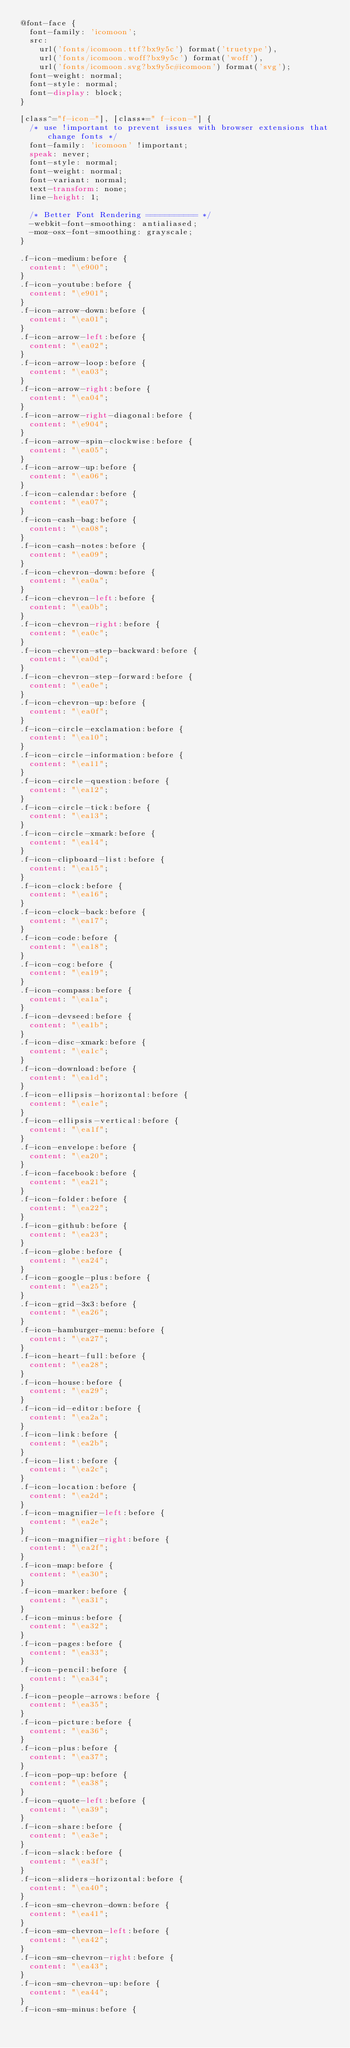Convert code to text. <code><loc_0><loc_0><loc_500><loc_500><_CSS_>@font-face {
  font-family: 'icomoon';
  src:
    url('fonts/icomoon.ttf?bx9y5c') format('truetype'),
    url('fonts/icomoon.woff?bx9y5c') format('woff'),
    url('fonts/icomoon.svg?bx9y5c#icomoon') format('svg');
  font-weight: normal;
  font-style: normal;
  font-display: block;
}

[class^="f-icon-"], [class*=" f-icon-"] {
  /* use !important to prevent issues with browser extensions that change fonts */
  font-family: 'icomoon' !important;
  speak: never;
  font-style: normal;
  font-weight: normal;
  font-variant: normal;
  text-transform: none;
  line-height: 1;

  /* Better Font Rendering =========== */
  -webkit-font-smoothing: antialiased;
  -moz-osx-font-smoothing: grayscale;
}

.f-icon-medium:before {
  content: "\e900";
}
.f-icon-youtube:before {
  content: "\e901";
}
.f-icon-arrow-down:before {
  content: "\ea01";
}
.f-icon-arrow-left:before {
  content: "\ea02";
}
.f-icon-arrow-loop:before {
  content: "\ea03";
}
.f-icon-arrow-right:before {
  content: "\ea04";
}
.f-icon-arrow-right-diagonal:before {
  content: "\e904";
}
.f-icon-arrow-spin-clockwise:before {
  content: "\ea05";
}
.f-icon-arrow-up:before {
  content: "\ea06";
}
.f-icon-calendar:before {
  content: "\ea07";
}
.f-icon-cash-bag:before {
  content: "\ea08";
}
.f-icon-cash-notes:before {
  content: "\ea09";
}
.f-icon-chevron-down:before {
  content: "\ea0a";
}
.f-icon-chevron-left:before {
  content: "\ea0b";
}
.f-icon-chevron-right:before {
  content: "\ea0c";
}
.f-icon-chevron-step-backward:before {
  content: "\ea0d";
}
.f-icon-chevron-step-forward:before {
  content: "\ea0e";
}
.f-icon-chevron-up:before {
  content: "\ea0f";
}
.f-icon-circle-exclamation:before {
  content: "\ea10";
}
.f-icon-circle-information:before {
  content: "\ea11";
}
.f-icon-circle-question:before {
  content: "\ea12";
}
.f-icon-circle-tick:before {
  content: "\ea13";
}
.f-icon-circle-xmark:before {
  content: "\ea14";
}
.f-icon-clipboard-list:before {
  content: "\ea15";
}
.f-icon-clock:before {
  content: "\ea16";
}
.f-icon-clock-back:before {
  content: "\ea17";
}
.f-icon-code:before {
  content: "\ea18";
}
.f-icon-cog:before {
  content: "\ea19";
}
.f-icon-compass:before {
  content: "\ea1a";
}
.f-icon-devseed:before {
  content: "\ea1b";
}
.f-icon-disc-xmark:before {
  content: "\ea1c";
}
.f-icon-download:before {
  content: "\ea1d";
}
.f-icon-ellipsis-horizontal:before {
  content: "\ea1e";
}
.f-icon-ellipsis-vertical:before {
  content: "\ea1f";
}
.f-icon-envelope:before {
  content: "\ea20";
}
.f-icon-facebook:before {
  content: "\ea21";
}
.f-icon-folder:before {
  content: "\ea22";
}
.f-icon-github:before {
  content: "\ea23";
}
.f-icon-globe:before {
  content: "\ea24";
}
.f-icon-google-plus:before {
  content: "\ea25";
}
.f-icon-grid-3x3:before {
  content: "\ea26";
}
.f-icon-hamburger-menu:before {
  content: "\ea27";
}
.f-icon-heart-full:before {
  content: "\ea28";
}
.f-icon-house:before {
  content: "\ea29";
}
.f-icon-id-editor:before {
  content: "\ea2a";
}
.f-icon-link:before {
  content: "\ea2b";
}
.f-icon-list:before {
  content: "\ea2c";
}
.f-icon-location:before {
  content: "\ea2d";
}
.f-icon-magnifier-left:before {
  content: "\ea2e";
}
.f-icon-magnifier-right:before {
  content: "\ea2f";
}
.f-icon-map:before {
  content: "\ea30";
}
.f-icon-marker:before {
  content: "\ea31";
}
.f-icon-minus:before {
  content: "\ea32";
}
.f-icon-pages:before {
  content: "\ea33";
}
.f-icon-pencil:before {
  content: "\ea34";
}
.f-icon-people-arrows:before {
  content: "\ea35";
}
.f-icon-picture:before {
  content: "\ea36";
}
.f-icon-plus:before {
  content: "\ea37";
}
.f-icon-pop-up:before {
  content: "\ea38";
}
.f-icon-quote-left:before {
  content: "\ea39";
}
.f-icon-share:before {
  content: "\ea3e";
}
.f-icon-slack:before {
  content: "\ea3f";
}
.f-icon-sliders-horizontal:before {
  content: "\ea40";
}
.f-icon-sm-chevron-down:before {
  content: "\ea41";
}
.f-icon-sm-chevron-left:before {
  content: "\ea42";
}
.f-icon-sm-chevron-right:before {
  content: "\ea43";
}
.f-icon-sm-chevron-up:before {
  content: "\ea44";
}
.f-icon-sm-minus:before {</code> 